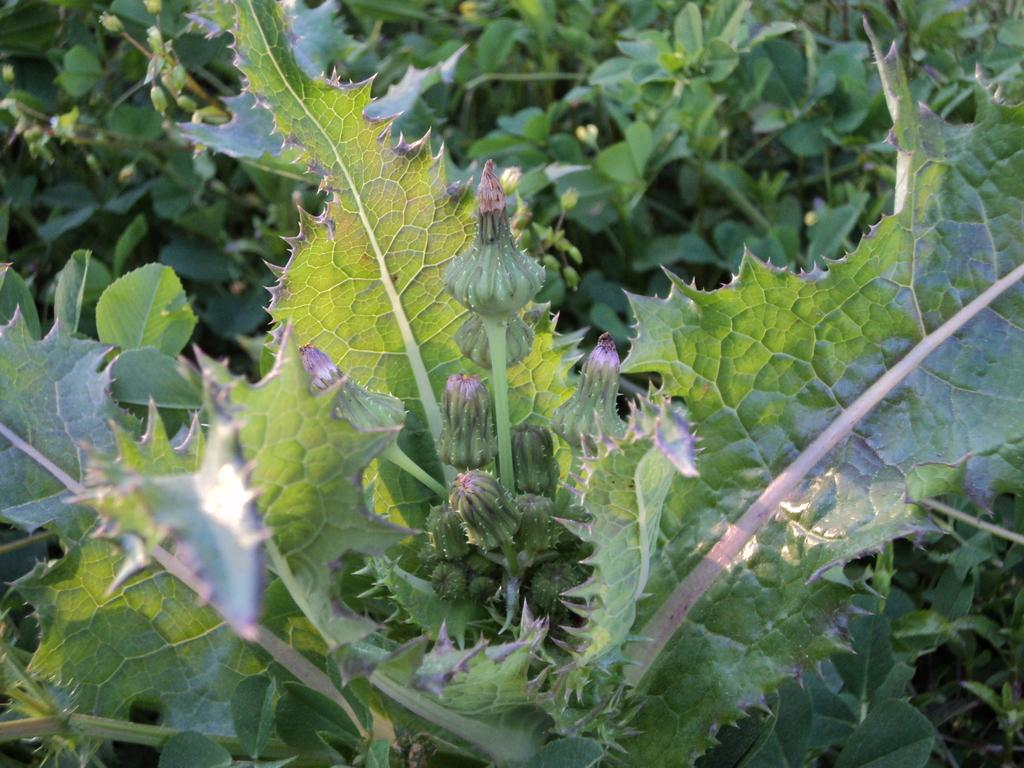What type of living organisms are in the image? The image contains plants. What part of the plants can be seen in the image? There are leaves and buds in the image. What type of nail is being used to tend to the plants in the image? There is no nail present in the image; it features plants, leaves, and buds. 